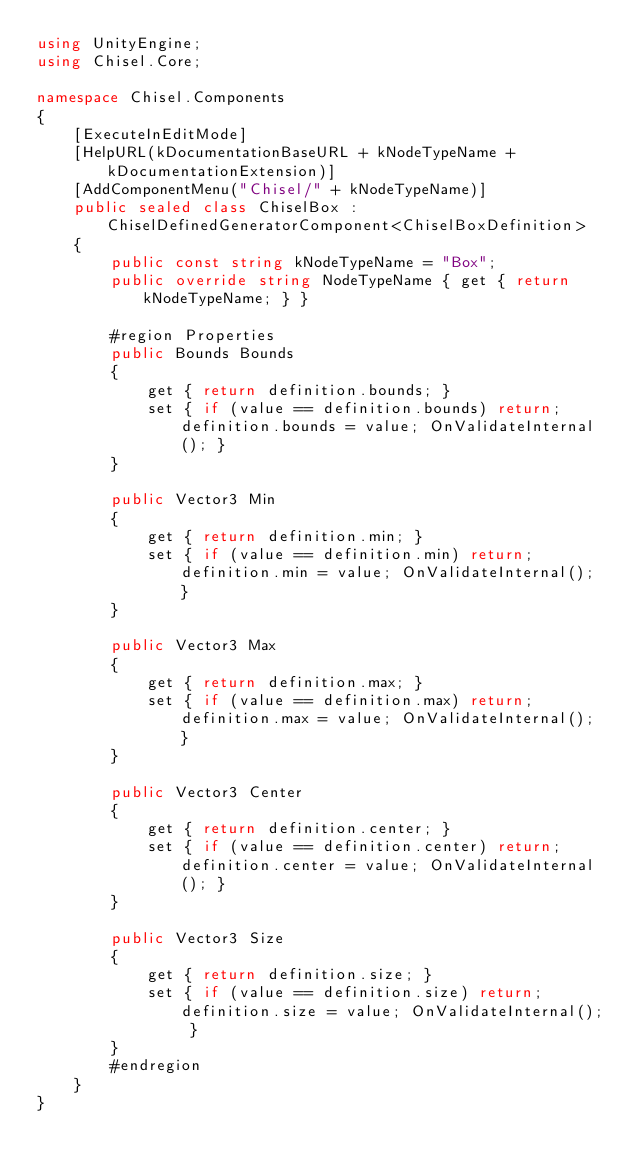Convert code to text. <code><loc_0><loc_0><loc_500><loc_500><_C#_>using UnityEngine;
using Chisel.Core;

namespace Chisel.Components
{
    [ExecuteInEditMode]
    [HelpURL(kDocumentationBaseURL + kNodeTypeName + kDocumentationExtension)]
    [AddComponentMenu("Chisel/" + kNodeTypeName)]
    public sealed class ChiselBox : ChiselDefinedGeneratorComponent<ChiselBoxDefinition>
    {
        public const string kNodeTypeName = "Box";
        public override string NodeTypeName { get { return kNodeTypeName; } }

        #region Properties
        public Bounds Bounds
        {
            get { return definition.bounds; }
            set { if (value == definition.bounds) return; definition.bounds = value; OnValidateInternal(); }
        }

        public Vector3 Min
        {
            get { return definition.min; }
            set { if (value == definition.min) return; definition.min = value; OnValidateInternal(); }
        }

        public Vector3 Max
        {
            get { return definition.max; }
            set { if (value == definition.max) return; definition.max = value; OnValidateInternal(); }
        }

        public Vector3 Center
        {
            get { return definition.center; }
            set { if (value == definition.center) return; definition.center = value; OnValidateInternal(); }
        }

        public Vector3 Size
        {
            get { return definition.size; }
            set { if (value == definition.size) return; definition.size = value; OnValidateInternal(); }
        }
        #endregion
    }
}</code> 